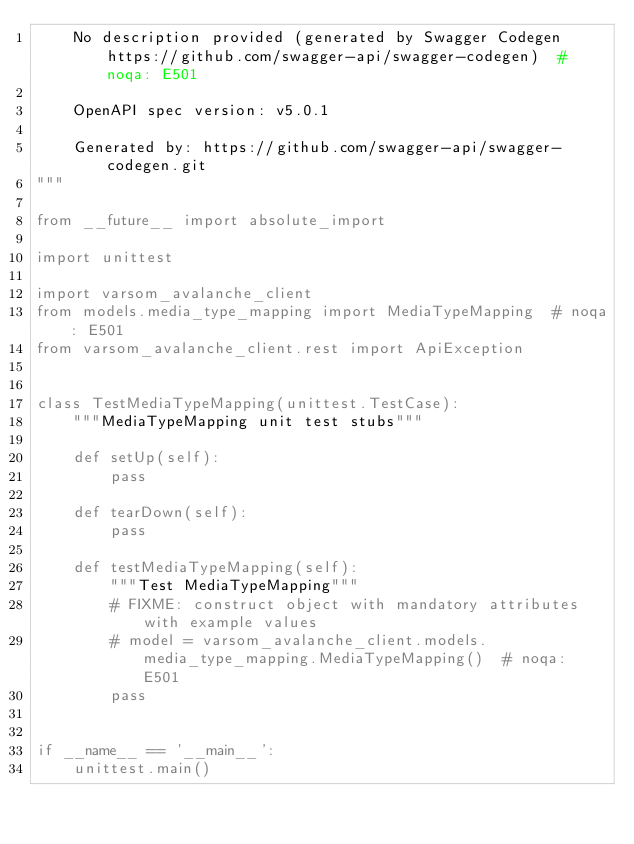Convert code to text. <code><loc_0><loc_0><loc_500><loc_500><_Python_>    No description provided (generated by Swagger Codegen https://github.com/swagger-api/swagger-codegen)  # noqa: E501

    OpenAPI spec version: v5.0.1
    
    Generated by: https://github.com/swagger-api/swagger-codegen.git
"""

from __future__ import absolute_import

import unittest

import varsom_avalanche_client
from models.media_type_mapping import MediaTypeMapping  # noqa: E501
from varsom_avalanche_client.rest import ApiException


class TestMediaTypeMapping(unittest.TestCase):
    """MediaTypeMapping unit test stubs"""

    def setUp(self):
        pass

    def tearDown(self):
        pass

    def testMediaTypeMapping(self):
        """Test MediaTypeMapping"""
        # FIXME: construct object with mandatory attributes with example values
        # model = varsom_avalanche_client.models.media_type_mapping.MediaTypeMapping()  # noqa: E501
        pass


if __name__ == '__main__':
    unittest.main()
</code> 